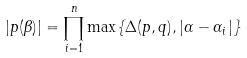<formula> <loc_0><loc_0><loc_500><loc_500>| p ( \beta ) | = \prod _ { i = 1 } ^ { n } \max \{ \Delta ( p , q ) , | \alpha - \alpha _ { i } | \}</formula> 